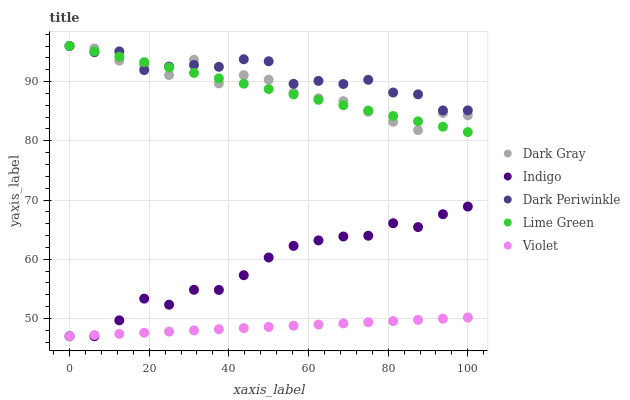Does Violet have the minimum area under the curve?
Answer yes or no. Yes. Does Dark Periwinkle have the maximum area under the curve?
Answer yes or no. Yes. Does Lime Green have the minimum area under the curve?
Answer yes or no. No. Does Lime Green have the maximum area under the curve?
Answer yes or no. No. Is Violet the smoothest?
Answer yes or no. Yes. Is Dark Gray the roughest?
Answer yes or no. Yes. Is Lime Green the smoothest?
Answer yes or no. No. Is Lime Green the roughest?
Answer yes or no. No. Does Indigo have the lowest value?
Answer yes or no. Yes. Does Lime Green have the lowest value?
Answer yes or no. No. Does Dark Periwinkle have the highest value?
Answer yes or no. Yes. Does Indigo have the highest value?
Answer yes or no. No. Is Violet less than Dark Periwinkle?
Answer yes or no. Yes. Is Lime Green greater than Indigo?
Answer yes or no. Yes. Does Dark Periwinkle intersect Lime Green?
Answer yes or no. Yes. Is Dark Periwinkle less than Lime Green?
Answer yes or no. No. Is Dark Periwinkle greater than Lime Green?
Answer yes or no. No. Does Violet intersect Dark Periwinkle?
Answer yes or no. No. 